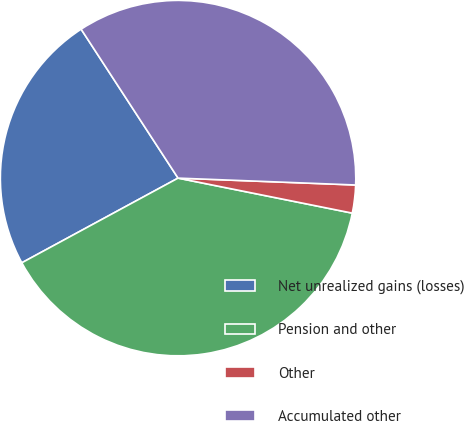<chart> <loc_0><loc_0><loc_500><loc_500><pie_chart><fcel>Net unrealized gains (losses)<fcel>Pension and other<fcel>Other<fcel>Accumulated other<nl><fcel>23.72%<fcel>38.94%<fcel>2.54%<fcel>34.8%<nl></chart> 